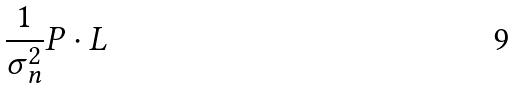Convert formula to latex. <formula><loc_0><loc_0><loc_500><loc_500>\frac { 1 } { \sigma _ { n } ^ { 2 } } P \cdot L</formula> 